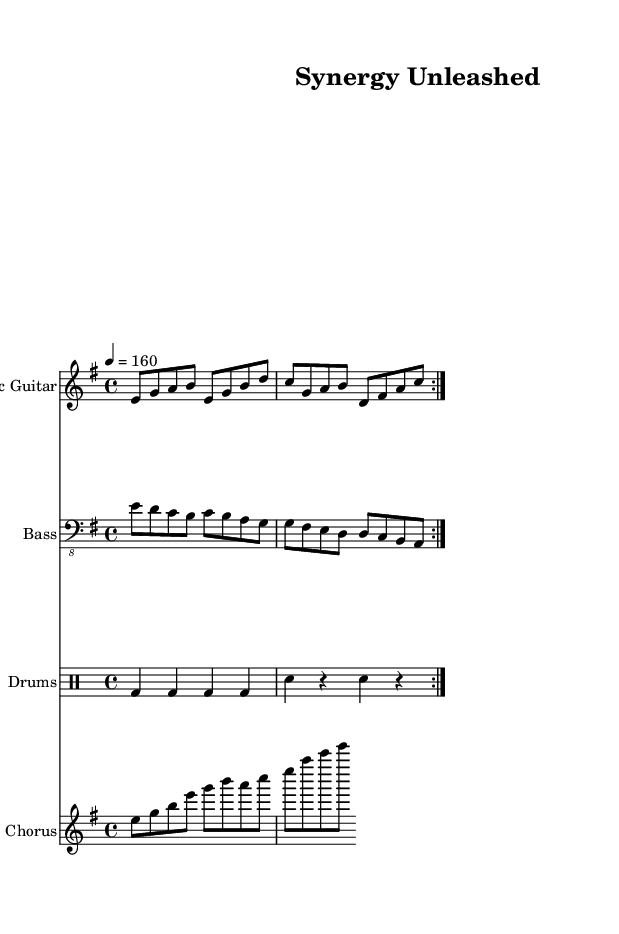what is the key signature of this music? The key signature is indicated at the beginning of the piece, showcasing E minor. Since E minor has one sharp (F#), the presence of one sharp helps identify the key.
Answer: E minor what is the time signature of this music? The time signature is denoted at the start as 4/4, meaning there are four beats in a measure and the quarter note gets one beat. This can be seen directly in the notation just after the key signature.
Answer: 4/4 what is the tempo marking for this music? The tempo is marked as 4 = 160, indicating the piece should be played at a speed of 160 beats per minute. This tempo instruction is commonly found in the header section of the music notation.
Answer: 160 how many measures are in the chorus part? The chorus section consists of one complete cycle with eight notes grouped, representing a total of one measure, but when repeated, there are two measures; hence, there are two measures for the chorus. To count the measures, one could observe the bars indicated in the chorus staff.
Answer: 2 what is the primary theme celebrated in this song? The lyrics clearly state "Mergers and acquisitions, power unleashed!", highlighting the theme focused on celebrating corporate successes in mergers and acquisitions. The overall tone of the song, along with the lyrics, reflects this theme, making it a distinctive power metal piece.
Answer: Mergers and acquisitions how many instruments are used in this composition? In the score, there are three distinct instrumental parts visible: Electric Guitar, Bass, and Drums. This can be determined by counting the different staves provided in the score layout.
Answer: 3 what type of musical mood does the tempo and key signature suggest? The combination of a fast tempo (160 bpm) and the E minor key generally denotes an energetic and powerful mood, characteristic of power metal. This reasoning stems from genre conventions where minor keys and brisk tempos often evoke intensity and strength.
Answer: Energetic and powerful 